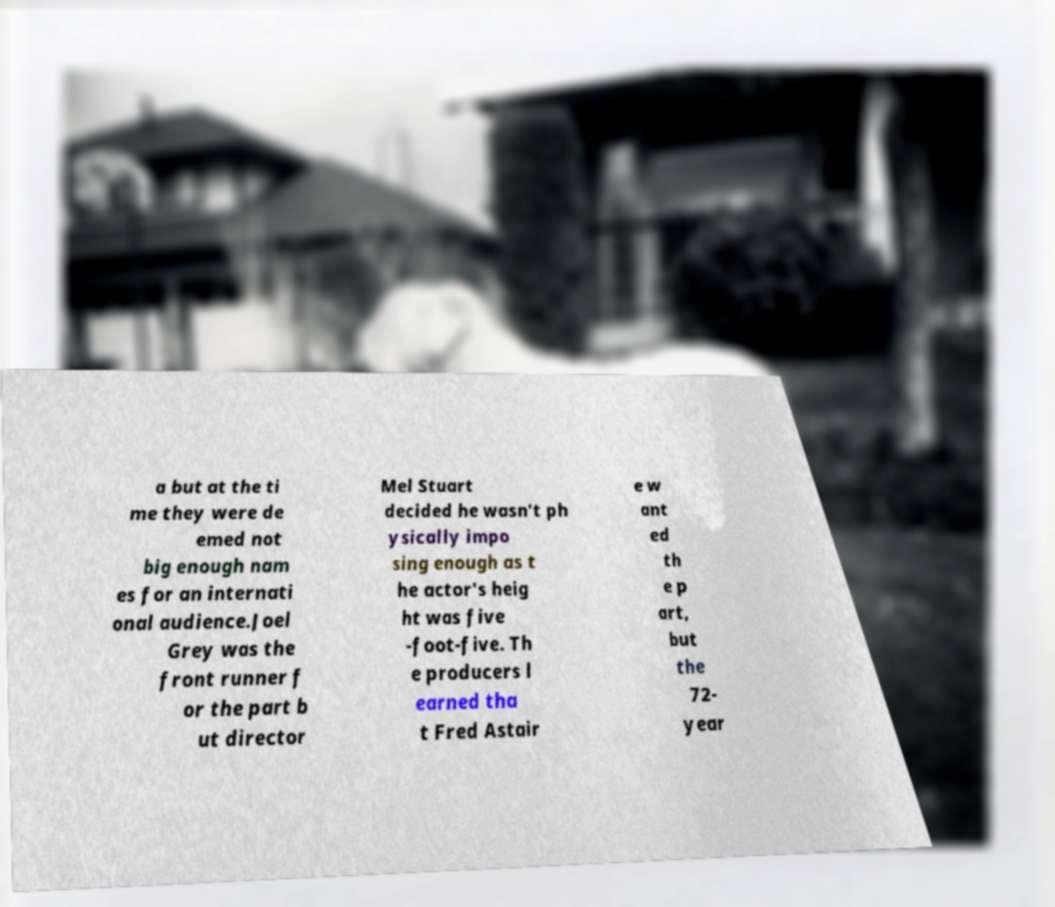Could you extract and type out the text from this image? a but at the ti me they were de emed not big enough nam es for an internati onal audience.Joel Grey was the front runner f or the part b ut director Mel Stuart decided he wasn’t ph ysically impo sing enough as t he actor's heig ht was five -foot-five. Th e producers l earned tha t Fred Astair e w ant ed th e p art, but the 72- year 